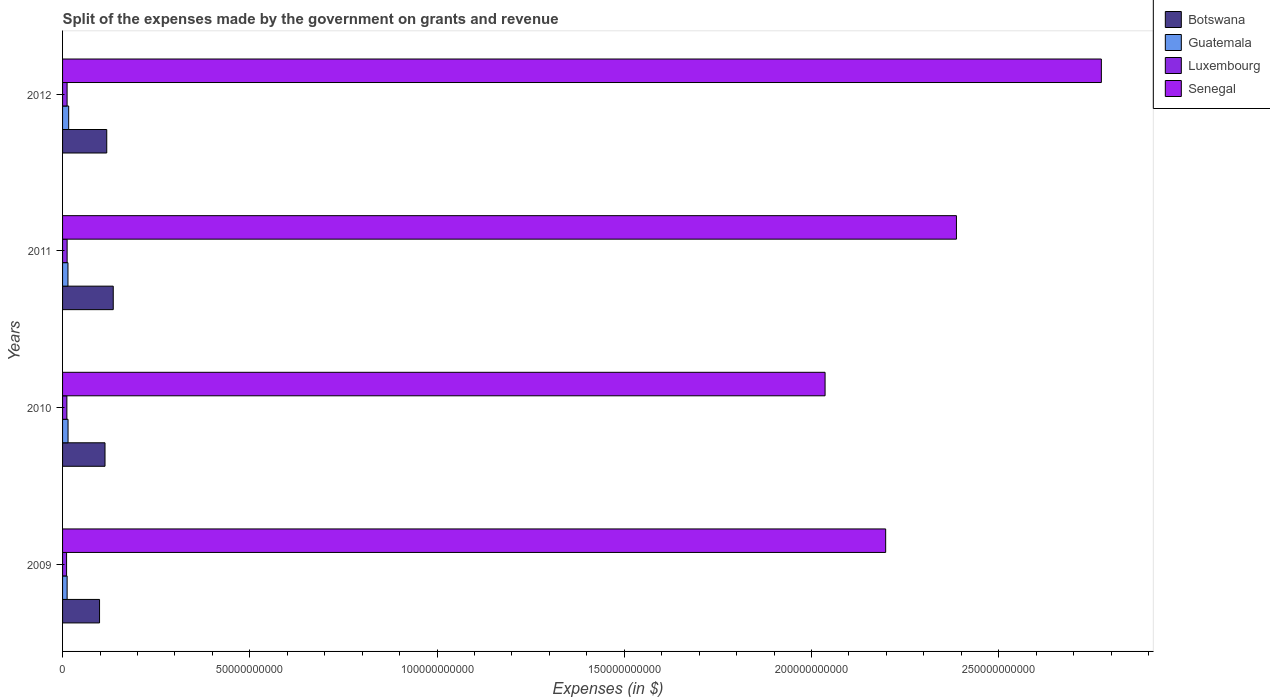How many different coloured bars are there?
Your response must be concise. 4. Are the number of bars per tick equal to the number of legend labels?
Your answer should be very brief. Yes. What is the label of the 3rd group of bars from the top?
Your answer should be very brief. 2010. In how many cases, is the number of bars for a given year not equal to the number of legend labels?
Make the answer very short. 0. What is the expenses made by the government on grants and revenue in Luxembourg in 2009?
Offer a very short reply. 1.07e+09. Across all years, what is the maximum expenses made by the government on grants and revenue in Guatemala?
Give a very brief answer. 1.64e+09. Across all years, what is the minimum expenses made by the government on grants and revenue in Botswana?
Your answer should be compact. 9.87e+09. What is the total expenses made by the government on grants and revenue in Guatemala in the graph?
Provide a succinct answer. 5.76e+09. What is the difference between the expenses made by the government on grants and revenue in Guatemala in 2010 and that in 2011?
Offer a very short reply. 2.46e+07. What is the difference between the expenses made by the government on grants and revenue in Botswana in 2010 and the expenses made by the government on grants and revenue in Senegal in 2012?
Offer a very short reply. -2.66e+11. What is the average expenses made by the government on grants and revenue in Botswana per year?
Your response must be concise. 1.16e+1. In the year 2012, what is the difference between the expenses made by the government on grants and revenue in Botswana and expenses made by the government on grants and revenue in Luxembourg?
Provide a short and direct response. 1.06e+1. What is the ratio of the expenses made by the government on grants and revenue in Senegal in 2009 to that in 2012?
Keep it short and to the point. 0.79. Is the expenses made by the government on grants and revenue in Botswana in 2010 less than that in 2011?
Ensure brevity in your answer.  Yes. Is the difference between the expenses made by the government on grants and revenue in Botswana in 2009 and 2011 greater than the difference between the expenses made by the government on grants and revenue in Luxembourg in 2009 and 2011?
Your response must be concise. No. What is the difference between the highest and the second highest expenses made by the government on grants and revenue in Luxembourg?
Offer a very short reply. 5.80e+06. What is the difference between the highest and the lowest expenses made by the government on grants and revenue in Guatemala?
Provide a short and direct response. 4.20e+08. Is it the case that in every year, the sum of the expenses made by the government on grants and revenue in Botswana and expenses made by the government on grants and revenue in Senegal is greater than the sum of expenses made by the government on grants and revenue in Guatemala and expenses made by the government on grants and revenue in Luxembourg?
Make the answer very short. Yes. What does the 2nd bar from the top in 2010 represents?
Your answer should be compact. Luxembourg. What does the 1st bar from the bottom in 2010 represents?
Your answer should be very brief. Botswana. Does the graph contain any zero values?
Your response must be concise. No. Does the graph contain grids?
Keep it short and to the point. No. Where does the legend appear in the graph?
Provide a succinct answer. Top right. How are the legend labels stacked?
Keep it short and to the point. Vertical. What is the title of the graph?
Your answer should be very brief. Split of the expenses made by the government on grants and revenue. Does "Kosovo" appear as one of the legend labels in the graph?
Offer a terse response. No. What is the label or title of the X-axis?
Give a very brief answer. Expenses (in $). What is the Expenses (in $) of Botswana in 2009?
Your answer should be compact. 9.87e+09. What is the Expenses (in $) in Guatemala in 2009?
Provide a short and direct response. 1.22e+09. What is the Expenses (in $) of Luxembourg in 2009?
Your response must be concise. 1.07e+09. What is the Expenses (in $) in Senegal in 2009?
Offer a very short reply. 2.20e+11. What is the Expenses (in $) in Botswana in 2010?
Your response must be concise. 1.13e+1. What is the Expenses (in $) of Guatemala in 2010?
Your response must be concise. 1.47e+09. What is the Expenses (in $) in Luxembourg in 2010?
Make the answer very short. 1.15e+09. What is the Expenses (in $) in Senegal in 2010?
Offer a very short reply. 2.04e+11. What is the Expenses (in $) of Botswana in 2011?
Your response must be concise. 1.35e+1. What is the Expenses (in $) in Guatemala in 2011?
Your response must be concise. 1.44e+09. What is the Expenses (in $) of Luxembourg in 2011?
Your answer should be compact. 1.22e+09. What is the Expenses (in $) in Senegal in 2011?
Provide a succinct answer. 2.39e+11. What is the Expenses (in $) of Botswana in 2012?
Your answer should be very brief. 1.18e+1. What is the Expenses (in $) of Guatemala in 2012?
Your response must be concise. 1.64e+09. What is the Expenses (in $) in Luxembourg in 2012?
Keep it short and to the point. 1.21e+09. What is the Expenses (in $) in Senegal in 2012?
Provide a succinct answer. 2.77e+11. Across all years, what is the maximum Expenses (in $) in Botswana?
Offer a terse response. 1.35e+1. Across all years, what is the maximum Expenses (in $) in Guatemala?
Your answer should be very brief. 1.64e+09. Across all years, what is the maximum Expenses (in $) in Luxembourg?
Your response must be concise. 1.22e+09. Across all years, what is the maximum Expenses (in $) in Senegal?
Give a very brief answer. 2.77e+11. Across all years, what is the minimum Expenses (in $) of Botswana?
Your response must be concise. 9.87e+09. Across all years, what is the minimum Expenses (in $) in Guatemala?
Give a very brief answer. 1.22e+09. Across all years, what is the minimum Expenses (in $) in Luxembourg?
Your response must be concise. 1.07e+09. Across all years, what is the minimum Expenses (in $) in Senegal?
Your answer should be compact. 2.04e+11. What is the total Expenses (in $) in Botswana in the graph?
Ensure brevity in your answer.  4.65e+1. What is the total Expenses (in $) of Guatemala in the graph?
Your answer should be very brief. 5.76e+09. What is the total Expenses (in $) in Luxembourg in the graph?
Provide a succinct answer. 4.65e+09. What is the total Expenses (in $) in Senegal in the graph?
Your answer should be compact. 9.40e+11. What is the difference between the Expenses (in $) of Botswana in 2009 and that in 2010?
Your answer should be very brief. -1.46e+09. What is the difference between the Expenses (in $) of Guatemala in 2009 and that in 2010?
Your answer should be compact. -2.49e+08. What is the difference between the Expenses (in $) in Luxembourg in 2009 and that in 2010?
Give a very brief answer. -8.02e+07. What is the difference between the Expenses (in $) of Senegal in 2009 and that in 2010?
Give a very brief answer. 1.62e+1. What is the difference between the Expenses (in $) in Botswana in 2009 and that in 2011?
Make the answer very short. -3.66e+09. What is the difference between the Expenses (in $) in Guatemala in 2009 and that in 2011?
Your answer should be compact. -2.25e+08. What is the difference between the Expenses (in $) of Luxembourg in 2009 and that in 2011?
Offer a terse response. -1.46e+08. What is the difference between the Expenses (in $) in Senegal in 2009 and that in 2011?
Make the answer very short. -1.89e+1. What is the difference between the Expenses (in $) of Botswana in 2009 and that in 2012?
Give a very brief answer. -1.93e+09. What is the difference between the Expenses (in $) in Guatemala in 2009 and that in 2012?
Keep it short and to the point. -4.20e+08. What is the difference between the Expenses (in $) in Luxembourg in 2009 and that in 2012?
Ensure brevity in your answer.  -1.41e+08. What is the difference between the Expenses (in $) in Senegal in 2009 and that in 2012?
Offer a terse response. -5.76e+1. What is the difference between the Expenses (in $) of Botswana in 2010 and that in 2011?
Keep it short and to the point. -2.20e+09. What is the difference between the Expenses (in $) in Guatemala in 2010 and that in 2011?
Provide a succinct answer. 2.46e+07. What is the difference between the Expenses (in $) in Luxembourg in 2010 and that in 2011?
Provide a short and direct response. -6.61e+07. What is the difference between the Expenses (in $) of Senegal in 2010 and that in 2011?
Provide a succinct answer. -3.51e+1. What is the difference between the Expenses (in $) of Botswana in 2010 and that in 2012?
Your answer should be very brief. -4.65e+08. What is the difference between the Expenses (in $) of Guatemala in 2010 and that in 2012?
Keep it short and to the point. -1.70e+08. What is the difference between the Expenses (in $) in Luxembourg in 2010 and that in 2012?
Give a very brief answer. -6.03e+07. What is the difference between the Expenses (in $) of Senegal in 2010 and that in 2012?
Your answer should be very brief. -7.38e+1. What is the difference between the Expenses (in $) in Botswana in 2011 and that in 2012?
Your response must be concise. 1.73e+09. What is the difference between the Expenses (in $) of Guatemala in 2011 and that in 2012?
Offer a terse response. -1.95e+08. What is the difference between the Expenses (in $) of Luxembourg in 2011 and that in 2012?
Your answer should be very brief. 5.80e+06. What is the difference between the Expenses (in $) in Senegal in 2011 and that in 2012?
Offer a terse response. -3.87e+1. What is the difference between the Expenses (in $) in Botswana in 2009 and the Expenses (in $) in Guatemala in 2010?
Your answer should be very brief. 8.41e+09. What is the difference between the Expenses (in $) in Botswana in 2009 and the Expenses (in $) in Luxembourg in 2010?
Your answer should be very brief. 8.72e+09. What is the difference between the Expenses (in $) of Botswana in 2009 and the Expenses (in $) of Senegal in 2010?
Provide a short and direct response. -1.94e+11. What is the difference between the Expenses (in $) of Guatemala in 2009 and the Expenses (in $) of Luxembourg in 2010?
Offer a terse response. 6.54e+07. What is the difference between the Expenses (in $) in Guatemala in 2009 and the Expenses (in $) in Senegal in 2010?
Give a very brief answer. -2.02e+11. What is the difference between the Expenses (in $) in Luxembourg in 2009 and the Expenses (in $) in Senegal in 2010?
Offer a terse response. -2.03e+11. What is the difference between the Expenses (in $) in Botswana in 2009 and the Expenses (in $) in Guatemala in 2011?
Your answer should be very brief. 8.43e+09. What is the difference between the Expenses (in $) in Botswana in 2009 and the Expenses (in $) in Luxembourg in 2011?
Offer a very short reply. 8.66e+09. What is the difference between the Expenses (in $) of Botswana in 2009 and the Expenses (in $) of Senegal in 2011?
Your response must be concise. -2.29e+11. What is the difference between the Expenses (in $) of Guatemala in 2009 and the Expenses (in $) of Luxembourg in 2011?
Provide a succinct answer. -7.33e+05. What is the difference between the Expenses (in $) of Guatemala in 2009 and the Expenses (in $) of Senegal in 2011?
Ensure brevity in your answer.  -2.37e+11. What is the difference between the Expenses (in $) in Luxembourg in 2009 and the Expenses (in $) in Senegal in 2011?
Provide a short and direct response. -2.38e+11. What is the difference between the Expenses (in $) of Botswana in 2009 and the Expenses (in $) of Guatemala in 2012?
Your answer should be compact. 8.24e+09. What is the difference between the Expenses (in $) of Botswana in 2009 and the Expenses (in $) of Luxembourg in 2012?
Make the answer very short. 8.66e+09. What is the difference between the Expenses (in $) of Botswana in 2009 and the Expenses (in $) of Senegal in 2012?
Keep it short and to the point. -2.68e+11. What is the difference between the Expenses (in $) of Guatemala in 2009 and the Expenses (in $) of Luxembourg in 2012?
Offer a very short reply. 5.06e+06. What is the difference between the Expenses (in $) of Guatemala in 2009 and the Expenses (in $) of Senegal in 2012?
Ensure brevity in your answer.  -2.76e+11. What is the difference between the Expenses (in $) of Luxembourg in 2009 and the Expenses (in $) of Senegal in 2012?
Give a very brief answer. -2.76e+11. What is the difference between the Expenses (in $) of Botswana in 2010 and the Expenses (in $) of Guatemala in 2011?
Offer a terse response. 9.89e+09. What is the difference between the Expenses (in $) in Botswana in 2010 and the Expenses (in $) in Luxembourg in 2011?
Ensure brevity in your answer.  1.01e+1. What is the difference between the Expenses (in $) of Botswana in 2010 and the Expenses (in $) of Senegal in 2011?
Keep it short and to the point. -2.27e+11. What is the difference between the Expenses (in $) in Guatemala in 2010 and the Expenses (in $) in Luxembourg in 2011?
Your answer should be compact. 2.49e+08. What is the difference between the Expenses (in $) of Guatemala in 2010 and the Expenses (in $) of Senegal in 2011?
Your answer should be compact. -2.37e+11. What is the difference between the Expenses (in $) of Luxembourg in 2010 and the Expenses (in $) of Senegal in 2011?
Your response must be concise. -2.38e+11. What is the difference between the Expenses (in $) in Botswana in 2010 and the Expenses (in $) in Guatemala in 2012?
Offer a very short reply. 9.70e+09. What is the difference between the Expenses (in $) in Botswana in 2010 and the Expenses (in $) in Luxembourg in 2012?
Provide a succinct answer. 1.01e+1. What is the difference between the Expenses (in $) of Botswana in 2010 and the Expenses (in $) of Senegal in 2012?
Provide a short and direct response. -2.66e+11. What is the difference between the Expenses (in $) of Guatemala in 2010 and the Expenses (in $) of Luxembourg in 2012?
Offer a very short reply. 2.54e+08. What is the difference between the Expenses (in $) of Guatemala in 2010 and the Expenses (in $) of Senegal in 2012?
Make the answer very short. -2.76e+11. What is the difference between the Expenses (in $) in Luxembourg in 2010 and the Expenses (in $) in Senegal in 2012?
Your response must be concise. -2.76e+11. What is the difference between the Expenses (in $) in Botswana in 2011 and the Expenses (in $) in Guatemala in 2012?
Ensure brevity in your answer.  1.19e+1. What is the difference between the Expenses (in $) of Botswana in 2011 and the Expenses (in $) of Luxembourg in 2012?
Your response must be concise. 1.23e+1. What is the difference between the Expenses (in $) of Botswana in 2011 and the Expenses (in $) of Senegal in 2012?
Make the answer very short. -2.64e+11. What is the difference between the Expenses (in $) in Guatemala in 2011 and the Expenses (in $) in Luxembourg in 2012?
Your answer should be compact. 2.30e+08. What is the difference between the Expenses (in $) of Guatemala in 2011 and the Expenses (in $) of Senegal in 2012?
Your answer should be compact. -2.76e+11. What is the difference between the Expenses (in $) of Luxembourg in 2011 and the Expenses (in $) of Senegal in 2012?
Provide a short and direct response. -2.76e+11. What is the average Expenses (in $) of Botswana per year?
Make the answer very short. 1.16e+1. What is the average Expenses (in $) of Guatemala per year?
Ensure brevity in your answer.  1.44e+09. What is the average Expenses (in $) of Luxembourg per year?
Give a very brief answer. 1.16e+09. What is the average Expenses (in $) in Senegal per year?
Your response must be concise. 2.35e+11. In the year 2009, what is the difference between the Expenses (in $) in Botswana and Expenses (in $) in Guatemala?
Give a very brief answer. 8.66e+09. In the year 2009, what is the difference between the Expenses (in $) in Botswana and Expenses (in $) in Luxembourg?
Give a very brief answer. 8.80e+09. In the year 2009, what is the difference between the Expenses (in $) in Botswana and Expenses (in $) in Senegal?
Ensure brevity in your answer.  -2.10e+11. In the year 2009, what is the difference between the Expenses (in $) of Guatemala and Expenses (in $) of Luxembourg?
Your response must be concise. 1.46e+08. In the year 2009, what is the difference between the Expenses (in $) in Guatemala and Expenses (in $) in Senegal?
Give a very brief answer. -2.19e+11. In the year 2009, what is the difference between the Expenses (in $) in Luxembourg and Expenses (in $) in Senegal?
Your response must be concise. -2.19e+11. In the year 2010, what is the difference between the Expenses (in $) of Botswana and Expenses (in $) of Guatemala?
Give a very brief answer. 9.87e+09. In the year 2010, what is the difference between the Expenses (in $) in Botswana and Expenses (in $) in Luxembourg?
Offer a very short reply. 1.02e+1. In the year 2010, what is the difference between the Expenses (in $) of Botswana and Expenses (in $) of Senegal?
Provide a short and direct response. -1.92e+11. In the year 2010, what is the difference between the Expenses (in $) of Guatemala and Expenses (in $) of Luxembourg?
Your response must be concise. 3.15e+08. In the year 2010, what is the difference between the Expenses (in $) in Guatemala and Expenses (in $) in Senegal?
Your answer should be very brief. -2.02e+11. In the year 2010, what is the difference between the Expenses (in $) of Luxembourg and Expenses (in $) of Senegal?
Your answer should be compact. -2.02e+11. In the year 2011, what is the difference between the Expenses (in $) of Botswana and Expenses (in $) of Guatemala?
Provide a short and direct response. 1.21e+1. In the year 2011, what is the difference between the Expenses (in $) in Botswana and Expenses (in $) in Luxembourg?
Provide a short and direct response. 1.23e+1. In the year 2011, what is the difference between the Expenses (in $) in Botswana and Expenses (in $) in Senegal?
Make the answer very short. -2.25e+11. In the year 2011, what is the difference between the Expenses (in $) in Guatemala and Expenses (in $) in Luxembourg?
Your answer should be very brief. 2.24e+08. In the year 2011, what is the difference between the Expenses (in $) of Guatemala and Expenses (in $) of Senegal?
Your answer should be compact. -2.37e+11. In the year 2011, what is the difference between the Expenses (in $) in Luxembourg and Expenses (in $) in Senegal?
Give a very brief answer. -2.37e+11. In the year 2012, what is the difference between the Expenses (in $) of Botswana and Expenses (in $) of Guatemala?
Keep it short and to the point. 1.02e+1. In the year 2012, what is the difference between the Expenses (in $) in Botswana and Expenses (in $) in Luxembourg?
Your answer should be compact. 1.06e+1. In the year 2012, what is the difference between the Expenses (in $) of Botswana and Expenses (in $) of Senegal?
Provide a short and direct response. -2.66e+11. In the year 2012, what is the difference between the Expenses (in $) of Guatemala and Expenses (in $) of Luxembourg?
Offer a very short reply. 4.25e+08. In the year 2012, what is the difference between the Expenses (in $) in Guatemala and Expenses (in $) in Senegal?
Provide a succinct answer. -2.76e+11. In the year 2012, what is the difference between the Expenses (in $) in Luxembourg and Expenses (in $) in Senegal?
Make the answer very short. -2.76e+11. What is the ratio of the Expenses (in $) in Botswana in 2009 to that in 2010?
Give a very brief answer. 0.87. What is the ratio of the Expenses (in $) in Guatemala in 2009 to that in 2010?
Your answer should be compact. 0.83. What is the ratio of the Expenses (in $) of Luxembourg in 2009 to that in 2010?
Offer a very short reply. 0.93. What is the ratio of the Expenses (in $) of Senegal in 2009 to that in 2010?
Make the answer very short. 1.08. What is the ratio of the Expenses (in $) of Botswana in 2009 to that in 2011?
Make the answer very short. 0.73. What is the ratio of the Expenses (in $) of Guatemala in 2009 to that in 2011?
Your answer should be very brief. 0.84. What is the ratio of the Expenses (in $) in Luxembourg in 2009 to that in 2011?
Give a very brief answer. 0.88. What is the ratio of the Expenses (in $) in Senegal in 2009 to that in 2011?
Your response must be concise. 0.92. What is the ratio of the Expenses (in $) in Botswana in 2009 to that in 2012?
Provide a short and direct response. 0.84. What is the ratio of the Expenses (in $) of Guatemala in 2009 to that in 2012?
Ensure brevity in your answer.  0.74. What is the ratio of the Expenses (in $) in Luxembourg in 2009 to that in 2012?
Provide a succinct answer. 0.88. What is the ratio of the Expenses (in $) in Senegal in 2009 to that in 2012?
Your answer should be very brief. 0.79. What is the ratio of the Expenses (in $) in Botswana in 2010 to that in 2011?
Your response must be concise. 0.84. What is the ratio of the Expenses (in $) in Guatemala in 2010 to that in 2011?
Offer a very short reply. 1.02. What is the ratio of the Expenses (in $) in Luxembourg in 2010 to that in 2011?
Ensure brevity in your answer.  0.95. What is the ratio of the Expenses (in $) of Senegal in 2010 to that in 2011?
Offer a very short reply. 0.85. What is the ratio of the Expenses (in $) in Botswana in 2010 to that in 2012?
Keep it short and to the point. 0.96. What is the ratio of the Expenses (in $) of Guatemala in 2010 to that in 2012?
Provide a succinct answer. 0.9. What is the ratio of the Expenses (in $) in Luxembourg in 2010 to that in 2012?
Keep it short and to the point. 0.95. What is the ratio of the Expenses (in $) in Senegal in 2010 to that in 2012?
Your response must be concise. 0.73. What is the ratio of the Expenses (in $) in Botswana in 2011 to that in 2012?
Offer a very short reply. 1.15. What is the ratio of the Expenses (in $) of Guatemala in 2011 to that in 2012?
Offer a terse response. 0.88. What is the ratio of the Expenses (in $) in Senegal in 2011 to that in 2012?
Keep it short and to the point. 0.86. What is the difference between the highest and the second highest Expenses (in $) in Botswana?
Offer a terse response. 1.73e+09. What is the difference between the highest and the second highest Expenses (in $) in Guatemala?
Offer a very short reply. 1.70e+08. What is the difference between the highest and the second highest Expenses (in $) in Luxembourg?
Your response must be concise. 5.80e+06. What is the difference between the highest and the second highest Expenses (in $) in Senegal?
Keep it short and to the point. 3.87e+1. What is the difference between the highest and the lowest Expenses (in $) in Botswana?
Ensure brevity in your answer.  3.66e+09. What is the difference between the highest and the lowest Expenses (in $) in Guatemala?
Give a very brief answer. 4.20e+08. What is the difference between the highest and the lowest Expenses (in $) of Luxembourg?
Offer a very short reply. 1.46e+08. What is the difference between the highest and the lowest Expenses (in $) of Senegal?
Offer a terse response. 7.38e+1. 